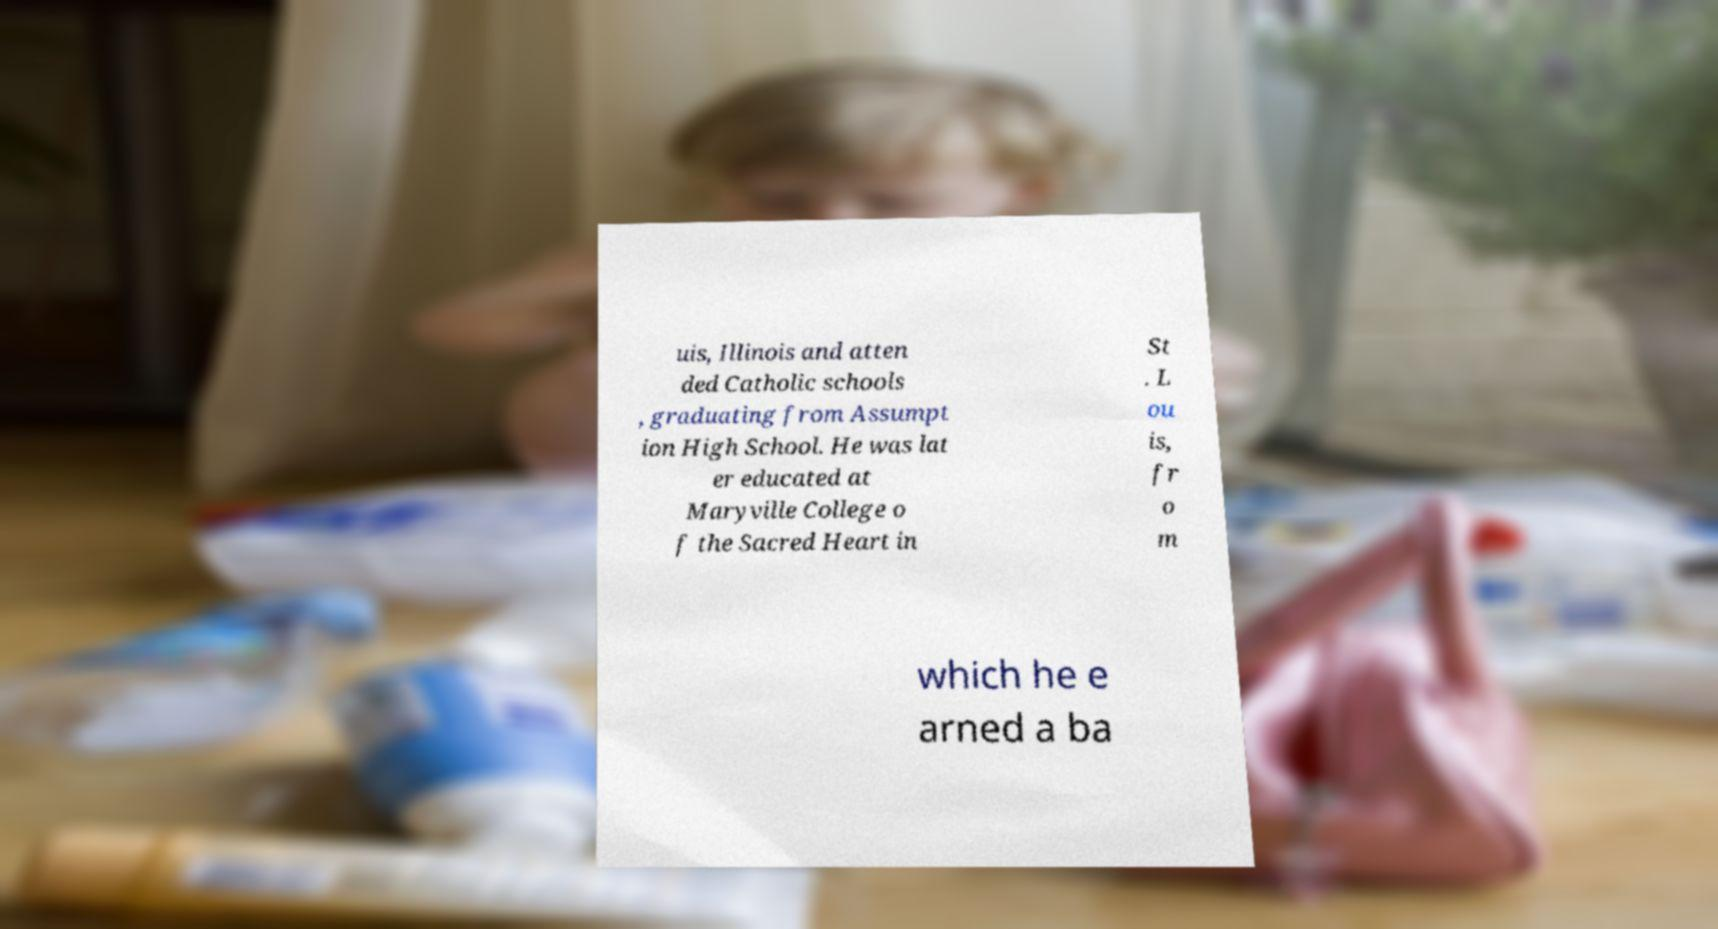Please read and relay the text visible in this image. What does it say? uis, Illinois and atten ded Catholic schools , graduating from Assumpt ion High School. He was lat er educated at Maryville College o f the Sacred Heart in St . L ou is, fr o m which he e arned a ba 